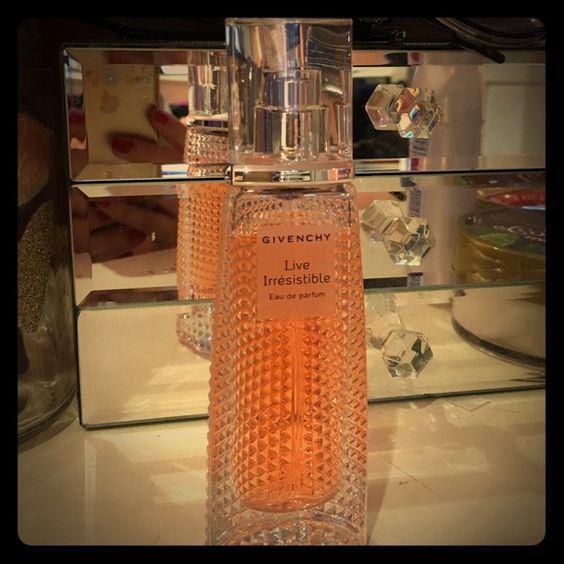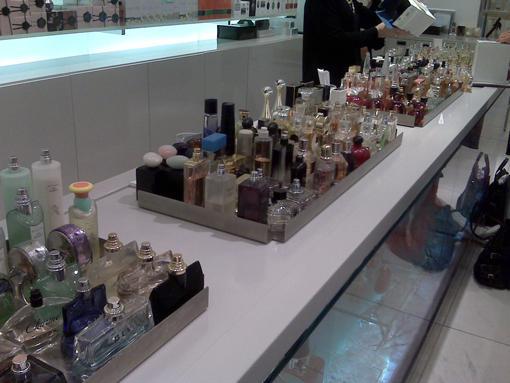The first image is the image on the left, the second image is the image on the right. Examine the images to the left and right. Is the description "The left image shows one glass fragrance bottle in a reflective glass display, and the right image shows a white shelf that angles up to the right and holds fragrance bottles." accurate? Answer yes or no. Yes. The first image is the image on the left, the second image is the image on the right. Examine the images to the left and right. Is the description "There are at least ten perfumes in the left image." accurate? Answer yes or no. No. 